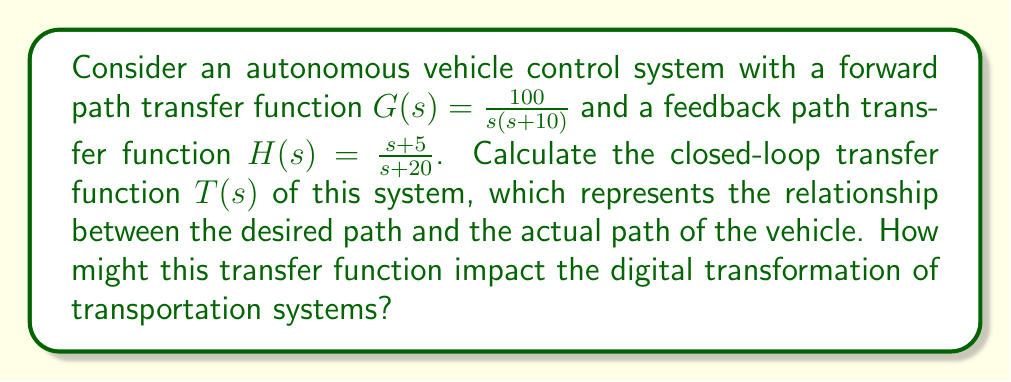Give your solution to this math problem. To solve this problem, we'll follow these steps:

1) The closed-loop transfer function for a negative feedback system is given by:

   $$T(s) = \frac{G(s)}{1 + G(s)H(s)}$$

2) We're given:
   $$G(s) = \frac{100}{s(s+10)}$$
   $$H(s) = \frac{s+5}{s+20}$$

3) Let's substitute these into our closed-loop transfer function equation:

   $$T(s) = \frac{\frac{100}{s(s+10)}}{1 + \frac{100}{s(s+10)} \cdot \frac{s+5}{s+20}}$$

4) To simplify this, let's first multiply the numerator and denominator by $s(s+10)(s+20)$:

   $$T(s) = \frac{100(s+20)}{s(s+10)(s+20) + 100(s+5)}$$

5) Expand the denominator:

   $$T(s) = \frac{100s + 2000}{s^3 + 30s^2 + 200s + 100s + 500}$$

6) Simplify:

   $$T(s) = \frac{100s + 2000}{s^3 + 30s^2 + 300s + 500}$$

This transfer function represents how the autonomous vehicle system responds to input commands. In the context of digital transformation, this mathematical model enables precise control and optimization of vehicle behavior, facilitating the development of more efficient and safer autonomous transportation systems.

The denominator of this transfer function is a third-order polynomial, indicating a potentially complex system behavior. The system's stability, speed of response, and accuracy can be analyzed using this transfer function, which is crucial for implementing robust autonomous driving algorithms in a digitally transformed transportation ecosystem.
Answer: $$T(s) = \frac{100s + 2000}{s^3 + 30s^2 + 300s + 500}$$ 